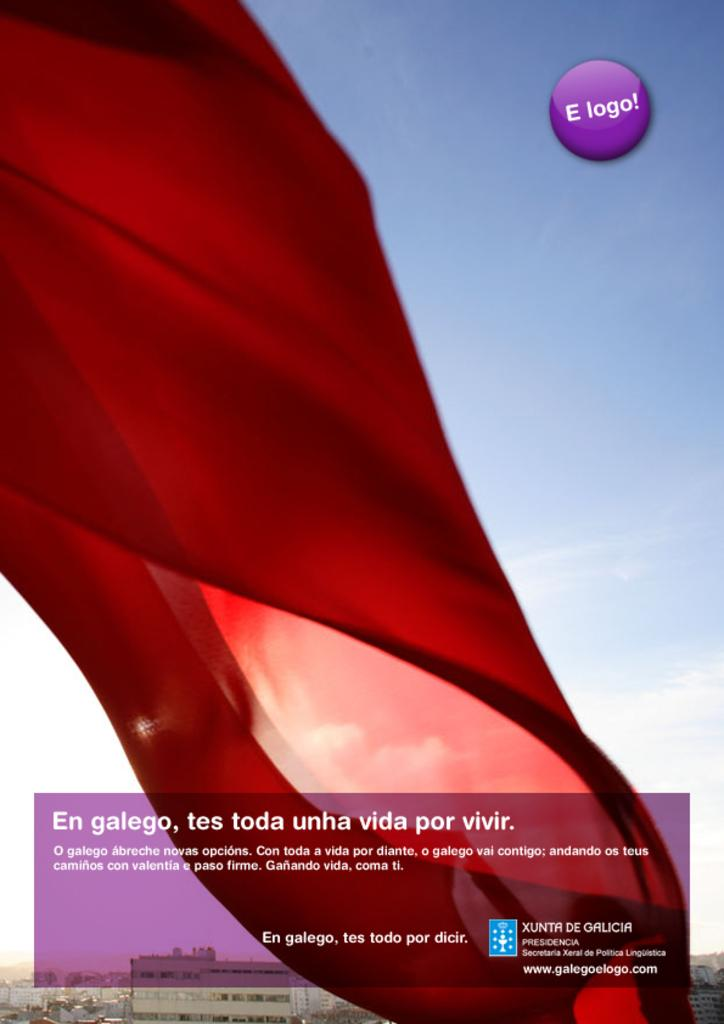Provide a one-sentence caption for the provided image. a large red curtain with an E logo sign next to it. 